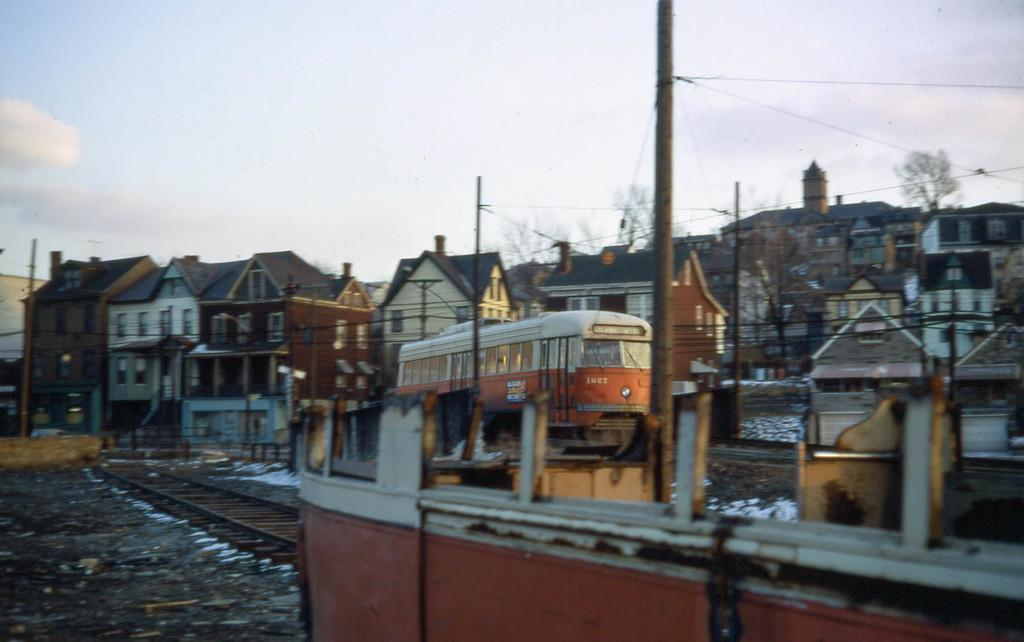What is the main subject in the foreground of the image? There is an object in the foreground of the image, but its specific nature is not mentioned in the facts. What can be seen in the background of the image? There are houses, trees, a train, a train track, poles, and the sky visible in the background of the image. How many types of structures are present in the background of the image? There are at least three types of structures present in the background: houses, a train, and poles. What is the natural environment visible in the background of the image? The natural environment includes trees and the sky. What type of trail can be seen leading to the camp in the image? There is no trail or camp present in the image. 